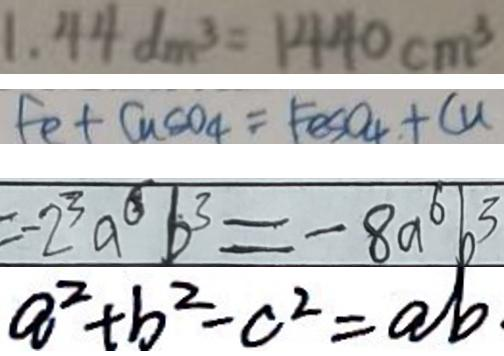<formula> <loc_0><loc_0><loc_500><loc_500>1 . 4 4 d m ^ { 3 } = 1 4 4 0 c m ^ { 3 } 
 F e + C u C o _ { 4 } = F e S O _ { 4 } + C u 
 = - 2 ^ { 3 } a ^ { 6 } b ^ { 3 } = - 8 a ^ { 6 } b ^ { 3 } 
 a ^ { 2 } + b ^ { 2 } - c ^ { 2 } = a b</formula> 